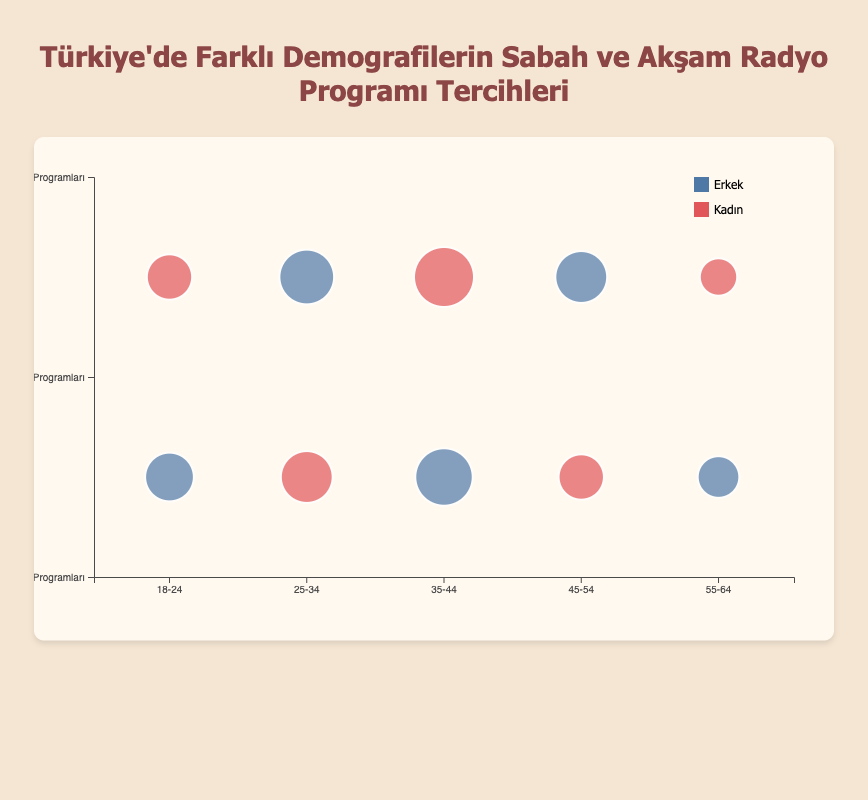Which age group has the largest bubble for morning show preference? To determine this, find the largest bubble among the age groups that prefer morning shows. For the age groups with morning show preferences, check the bubble sizes: 18-24 (30), 25-34 (35), 35-44 (45), 45-54 (25), 55-64 (20). The largest bubble is 45 for age group 35-44.
Answer: 35-44 Which gender prefers evening shows more in the 25-34 age group? Check the bubbles for the 25-34 age group for evening show preferences. The sizes are: Male (40) and Female (Morning Shows, not relevant). Therefore, males prefer evening shows more in this age group.
Answer: Male What is the total bubble size for morning show preferences in all age groups? Sum the bubble sizes of all age groups that prefer morning shows: 18-24 (30), 25-34 (35), 35-44 (45), 45-54 (25), 55-64 (20). Total = 30 + 35 + 45 + 25 + 20 = 155.
Answer: 155 For the 45-54 age group, which show time preference has a larger bubble size? Compare the bubble sizes for morning and evening shows in the 45-54 age group: Morning Shows (25), Evening Shows (35). The bubble for evening shows is larger.
Answer: Evening Shows Which is the most popular preference among females in the 35-44 age group? Check the bubble sizes for females in the 35-44 age group: Evening Shows (50), Morning Shows (not relevant). The most popular preference is evening shows.
Answer: Evening Shows How many age groups have a larger bubble size for morning shows compared to evening shows? Compare the bubble sizes for morning and evening shows across all age groups: 18-24 (Morning 30, Evening 25), 25-34 (Morning 35, Evening 40), 35-44 (Morning 45, Evening 50), 45-54 (Morning 25, Evening 35), 55-64 (Morning 20, Evening 15). Only one age group, 55-64, has a larger bubble size for morning shows.
Answer: 1 What is the average bubble size for male preferences in morning shows across all age groups? Sum the bubble sizes for male preferences in morning shows: 18-24 (30), 35-44 (45), 55-64 (20). Total = 30 + 45 + 20 = 95. There are 3 age groups involved, so the average is 95 / 3 ≈ 31.67.
Answer: 31.67 Which gender has a higher preference for evening shows in the 55-64 age group? In the 55-64 age group, compare bubble sizes: Male (Morning Shows, not relevant), Female (Evening Shows 15). Only females have a preference for evening shows.
Answer: Female 